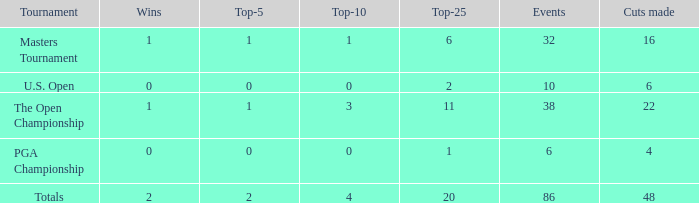State the complete sum of events for the tournament of masters and top 25 fewer than 0.0. 